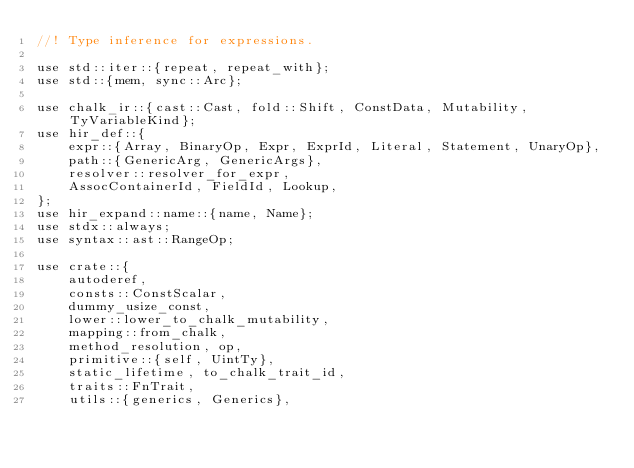<code> <loc_0><loc_0><loc_500><loc_500><_Rust_>//! Type inference for expressions.

use std::iter::{repeat, repeat_with};
use std::{mem, sync::Arc};

use chalk_ir::{cast::Cast, fold::Shift, ConstData, Mutability, TyVariableKind};
use hir_def::{
    expr::{Array, BinaryOp, Expr, ExprId, Literal, Statement, UnaryOp},
    path::{GenericArg, GenericArgs},
    resolver::resolver_for_expr,
    AssocContainerId, FieldId, Lookup,
};
use hir_expand::name::{name, Name};
use stdx::always;
use syntax::ast::RangeOp;

use crate::{
    autoderef,
    consts::ConstScalar,
    dummy_usize_const,
    lower::lower_to_chalk_mutability,
    mapping::from_chalk,
    method_resolution, op,
    primitive::{self, UintTy},
    static_lifetime, to_chalk_trait_id,
    traits::FnTrait,
    utils::{generics, Generics},</code> 